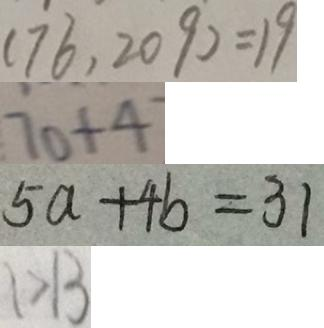Convert formula to latex. <formula><loc_0><loc_0><loc_500><loc_500>( 7 6 , 2 0 9 ) = 1 9 
 7 0 + 4 
 5 a + 4 b = 3 1 
 1 > 1 3</formula> 